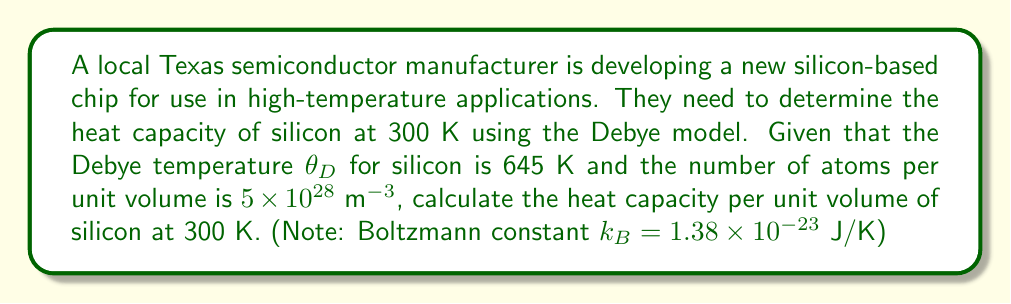Provide a solution to this math problem. To solve this problem, we'll use the Debye model for the heat capacity of a solid. The steps are as follows:

1) The Debye model gives the heat capacity per unit volume as:

   $$C_V = 9Nk_B \left(\frac{T}{\theta_D}\right)^3 \int_0^{\theta_D/T} \frac{x^4e^x}{(e^x-1)^2} dx$$

   where $N$ is the number of atoms per unit volume, $k_B$ is the Boltzmann constant, $T$ is the temperature, and $\theta_D$ is the Debye temperature.

2) We are given:
   $N = 5 \times 10^{28}$ m$^{-3}$
   $k_B = 1.38 \times 10^{-23}$ J/K
   $T = 300$ K
   $\theta_D = 645$ K

3) Calculate $T/\theta_D$:
   $$\frac{T}{\theta_D} = \frac{300}{645} \approx 0.465$$

4) The integral in the equation is a function of $\theta_D/T$. At $T/\theta_D = 0.465$, the value of this integral is approximately 0.791 (this value is typically found using numerical integration or tables).

5) Now we can substitute all values into the equation:

   $$C_V = 9 \times (5 \times 10^{28}) \times (1.38 \times 10^{-23}) \times (0.465)^3 \times 0.791$$

6) Calculating this gives:
   $$C_V \approx 1.94 \times 10^6 \text{ J/(m}^3\text{K)}$$
Answer: $1.94 \times 10^6$ J/(m$^3$K) 